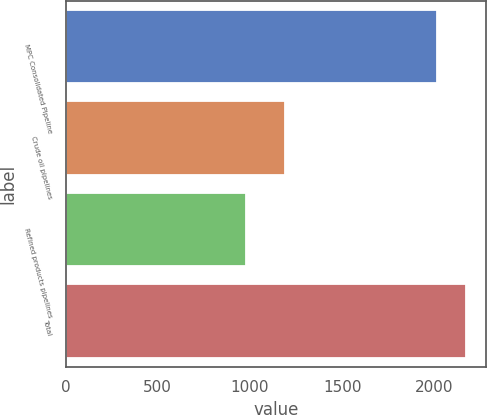Convert chart. <chart><loc_0><loc_0><loc_500><loc_500><bar_chart><fcel>MPC Consolidated Pipeline<fcel>Crude oil pipelines<fcel>Refined products pipelines<fcel>Total<nl><fcel>2012<fcel>1190<fcel>980<fcel>2170<nl></chart> 